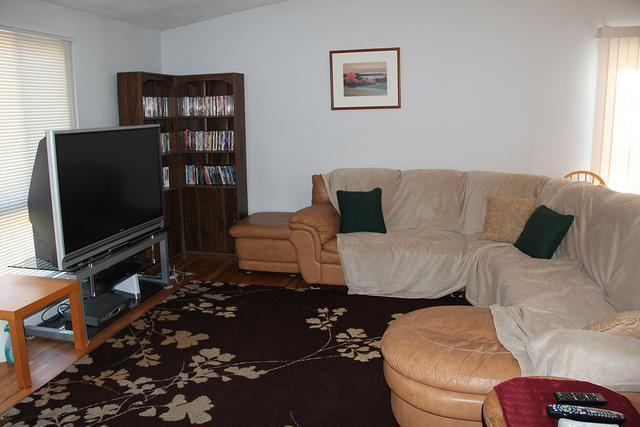How many portraits are hung on the white wall?
Pick the right solution, then justify: 'Answer: answer
Rationale: rationale.'
Options: Three, two, four, one. Answer: one.
Rationale: There is one portrait hung on the white wall. 